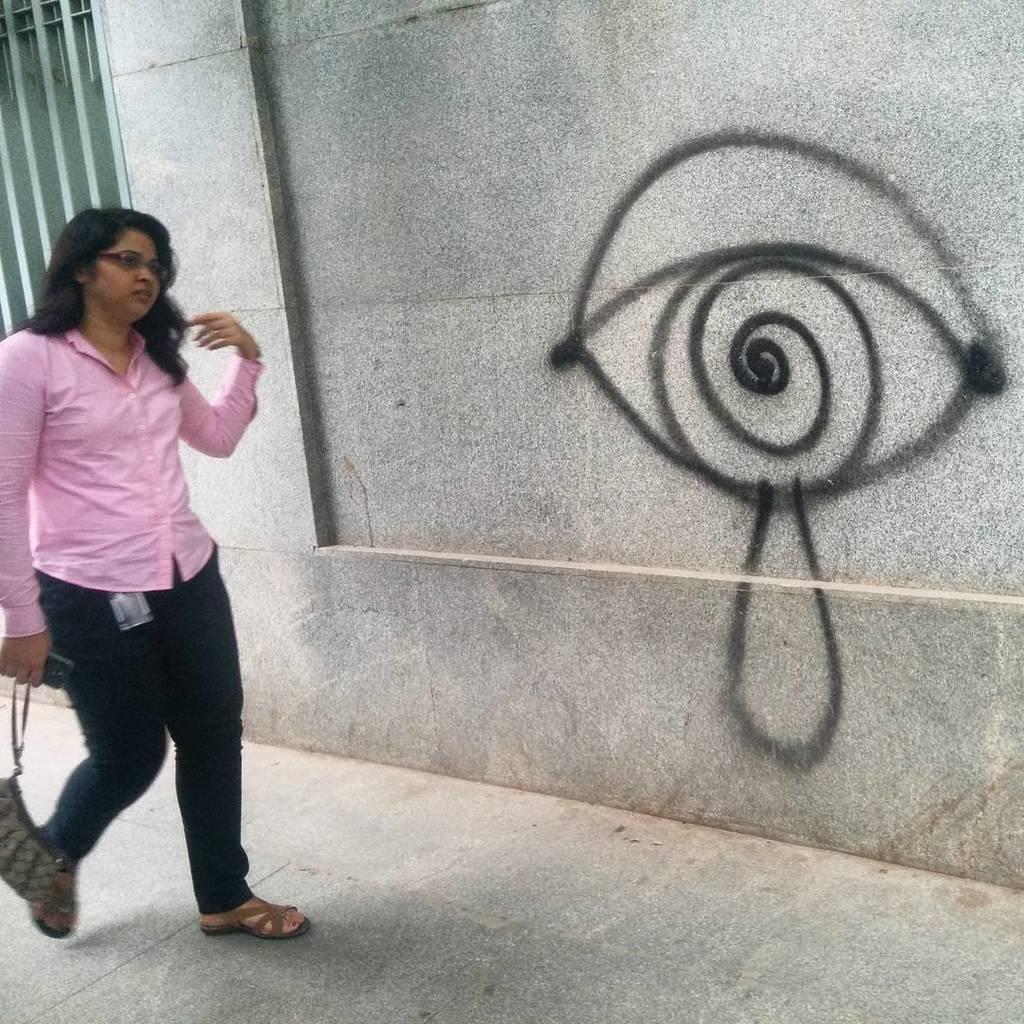Could you give a brief overview of what you see in this image? In this image in the center there is a woman walking and holding purse and a mobile phone in her hand. In the background there is a drawing on the wall. 